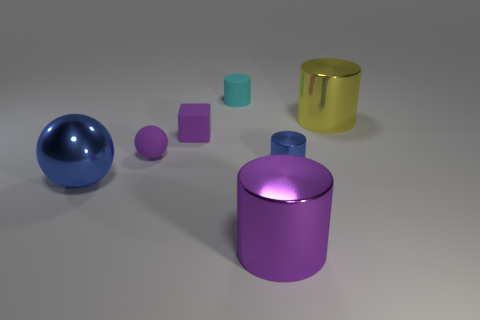Add 2 cyan cylinders. How many objects exist? 9 Subtract all blocks. How many objects are left? 6 Add 1 small blue shiny cylinders. How many small blue shiny cylinders are left? 2 Add 3 small purple matte cylinders. How many small purple matte cylinders exist? 3 Subtract 0 gray cylinders. How many objects are left? 7 Subtract all small cylinders. Subtract all small blue metal cylinders. How many objects are left? 4 